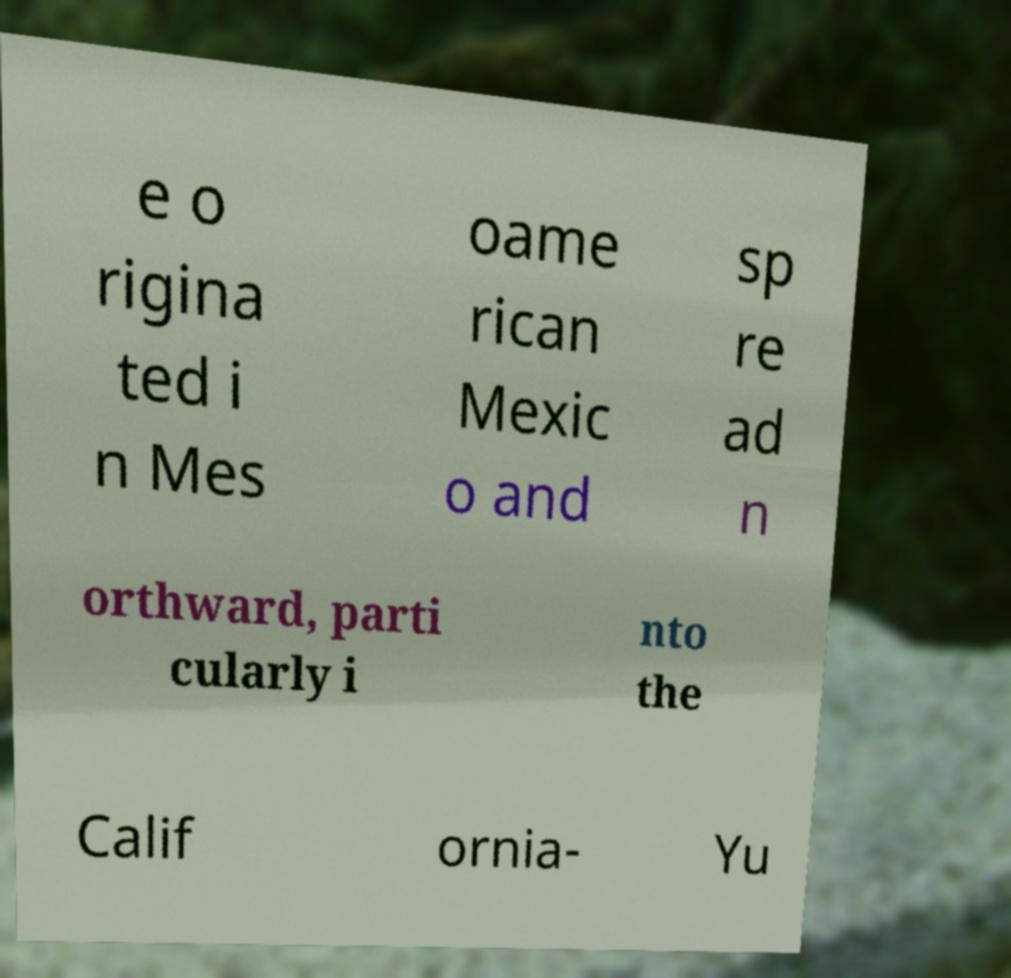There's text embedded in this image that I need extracted. Can you transcribe it verbatim? e o rigina ted i n Mes oame rican Mexic o and sp re ad n orthward, parti cularly i nto the Calif ornia- Yu 